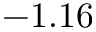<formula> <loc_0><loc_0><loc_500><loc_500>- 1 . 1 6</formula> 